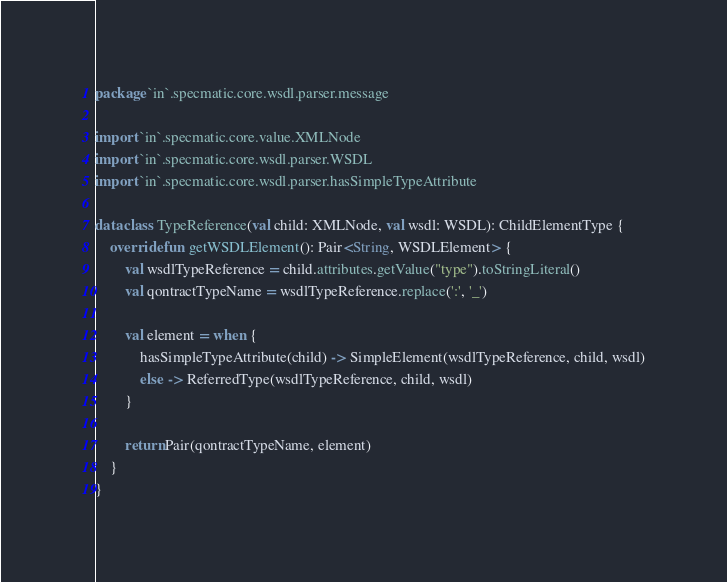<code> <loc_0><loc_0><loc_500><loc_500><_Kotlin_>package `in`.specmatic.core.wsdl.parser.message

import `in`.specmatic.core.value.XMLNode
import `in`.specmatic.core.wsdl.parser.WSDL
import `in`.specmatic.core.wsdl.parser.hasSimpleTypeAttribute

data class TypeReference(val child: XMLNode, val wsdl: WSDL): ChildElementType {
    override fun getWSDLElement(): Pair<String, WSDLElement> {
        val wsdlTypeReference = child.attributes.getValue("type").toStringLiteral()
        val qontractTypeName = wsdlTypeReference.replace(':', '_')

        val element = when {
            hasSimpleTypeAttribute(child) -> SimpleElement(wsdlTypeReference, child, wsdl)
            else -> ReferredType(wsdlTypeReference, child, wsdl)
        }

        return Pair(qontractTypeName, element)
    }
}</code> 